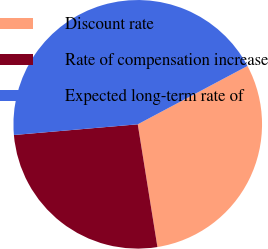Convert chart to OTSL. <chart><loc_0><loc_0><loc_500><loc_500><pie_chart><fcel>Discount rate<fcel>Rate of compensation increase<fcel>Expected long-term rate of<nl><fcel>30.25%<fcel>26.16%<fcel>43.6%<nl></chart> 